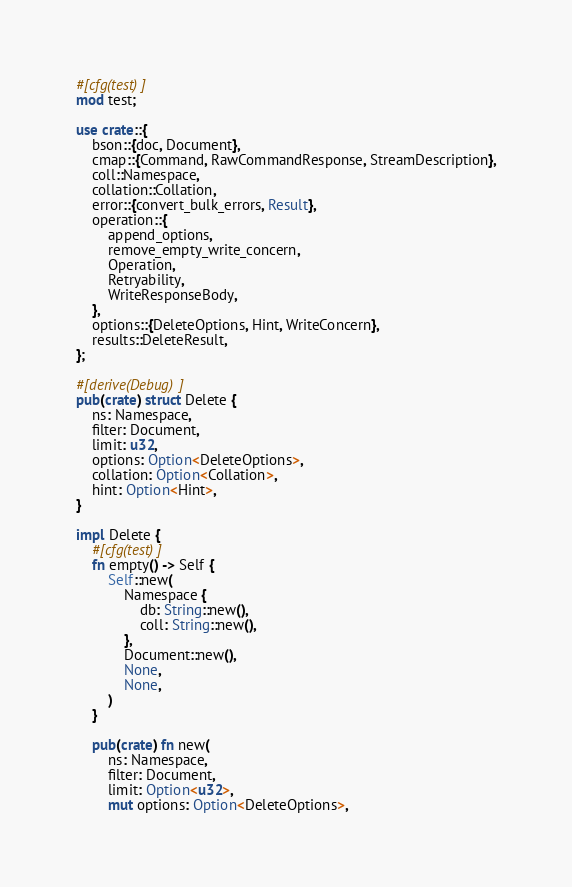Convert code to text. <code><loc_0><loc_0><loc_500><loc_500><_Rust_>#[cfg(test)]
mod test;

use crate::{
    bson::{doc, Document},
    cmap::{Command, RawCommandResponse, StreamDescription},
    coll::Namespace,
    collation::Collation,
    error::{convert_bulk_errors, Result},
    operation::{
        append_options,
        remove_empty_write_concern,
        Operation,
        Retryability,
        WriteResponseBody,
    },
    options::{DeleteOptions, Hint, WriteConcern},
    results::DeleteResult,
};

#[derive(Debug)]
pub(crate) struct Delete {
    ns: Namespace,
    filter: Document,
    limit: u32,
    options: Option<DeleteOptions>,
    collation: Option<Collation>,
    hint: Option<Hint>,
}

impl Delete {
    #[cfg(test)]
    fn empty() -> Self {
        Self::new(
            Namespace {
                db: String::new(),
                coll: String::new(),
            },
            Document::new(),
            None,
            None,
        )
    }

    pub(crate) fn new(
        ns: Namespace,
        filter: Document,
        limit: Option<u32>,
        mut options: Option<DeleteOptions>,</code> 